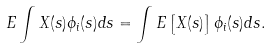<formula> <loc_0><loc_0><loc_500><loc_500>E \int X ( s ) \phi _ { i } ( s ) d s = \int E \left [ X ( s ) \right ] \phi _ { i } ( s ) d s .</formula> 